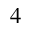Convert formula to latex. <formula><loc_0><loc_0><loc_500><loc_500>4</formula> 